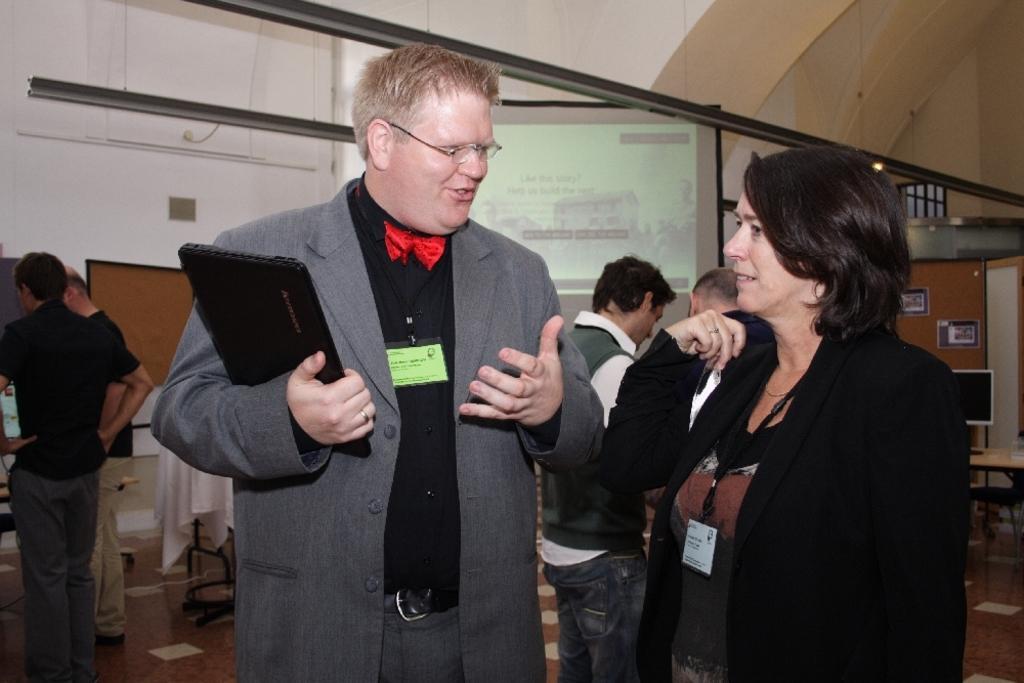Describe this image in one or two sentences. This image consists of a man and a woman talking. Both are wearing suits. In the background, there are many people and a screen. It looks like a hall. At the bottom, there is a floor. 